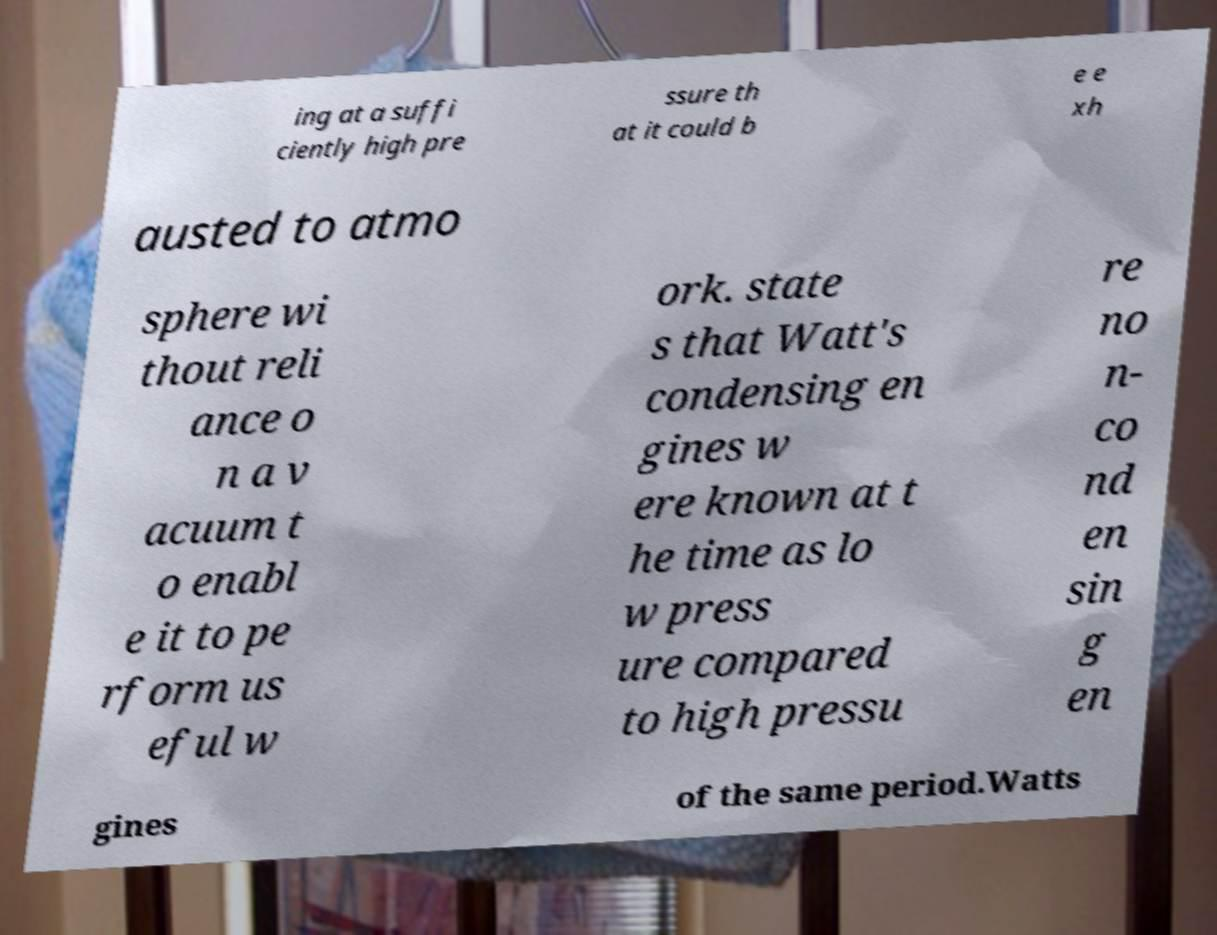Please read and relay the text visible in this image. What does it say? ing at a suffi ciently high pre ssure th at it could b e e xh austed to atmo sphere wi thout reli ance o n a v acuum t o enabl e it to pe rform us eful w ork. state s that Watt's condensing en gines w ere known at t he time as lo w press ure compared to high pressu re no n- co nd en sin g en gines of the same period.Watts 